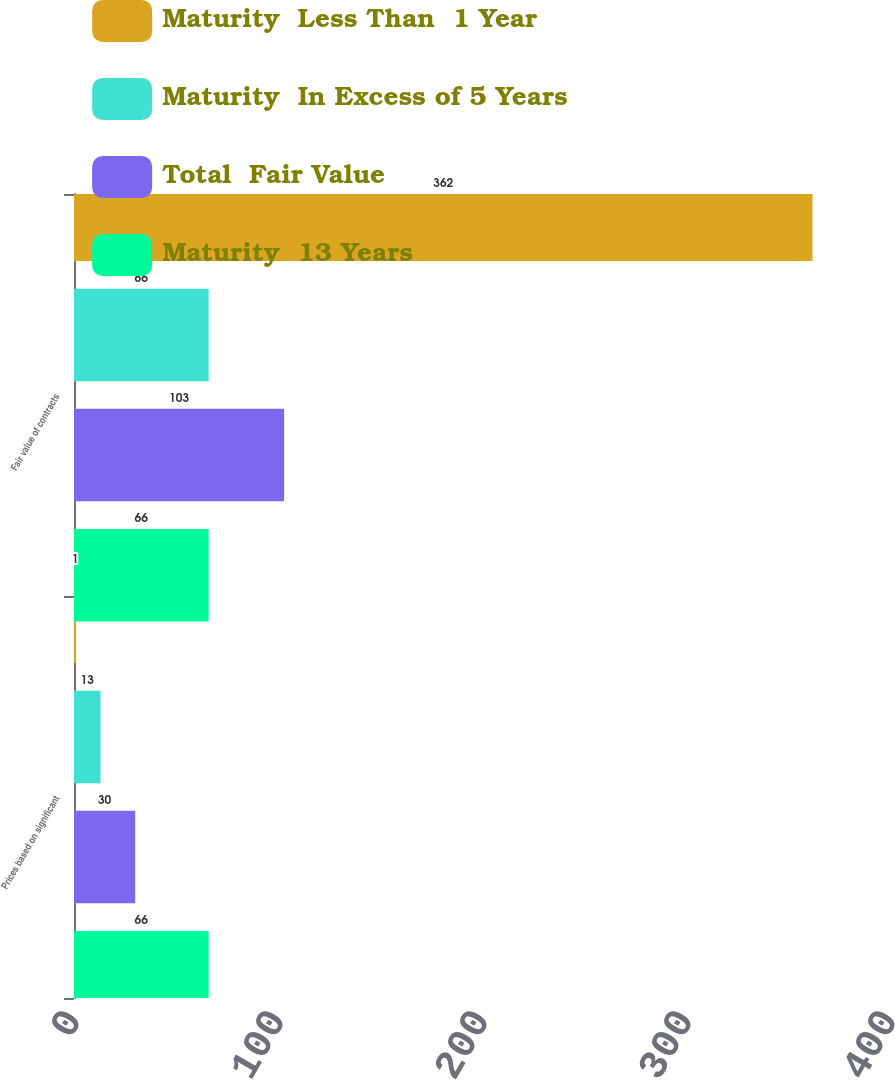Convert chart. <chart><loc_0><loc_0><loc_500><loc_500><stacked_bar_chart><ecel><fcel>Prices based on significant<fcel>Fair value of contracts<nl><fcel>Maturity  Less Than  1 Year<fcel>1<fcel>362<nl><fcel>Maturity  In Excess of 5 Years<fcel>13<fcel>66<nl><fcel>Total  Fair Value<fcel>30<fcel>103<nl><fcel>Maturity  13 Years<fcel>66<fcel>66<nl></chart> 